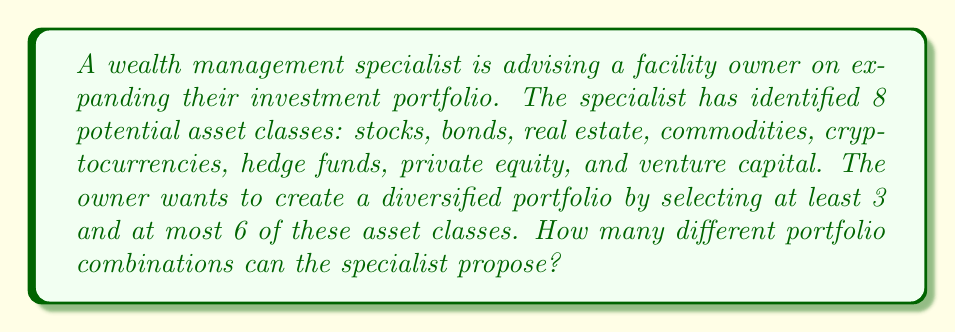Show me your answer to this math problem. Let's approach this step-by-step:

1) We need to calculate the sum of combinations for selecting 3, 4, 5, and 6 asset classes out of 8.

2) The formula for combinations is:

   $C(n,r) = \frac{n!}{r!(n-r)!}$

   where $n$ is the total number of items and $r$ is the number of items being chosen.

3) Let's calculate each combination:

   For 3 asset classes: $C(8,3) = \frac{8!}{3!(8-3)!} = \frac{8!}{3!5!} = 56$

   For 4 asset classes: $C(8,4) = \frac{8!}{4!(8-4)!} = \frac{8!}{4!4!} = 70$

   For 5 asset classes: $C(8,5) = \frac{8!}{5!(8-5)!} = \frac{8!}{5!3!} = 56$

   For 6 asset classes: $C(8,6) = \frac{8!}{6!(8-6)!} = \frac{8!}{6!2!} = 28$

4) The total number of possible portfolio combinations is the sum of these:

   $56 + 70 + 56 + 28 = 210$

Therefore, the wealth management specialist can propose 210 different portfolio combinations.
Answer: 210 